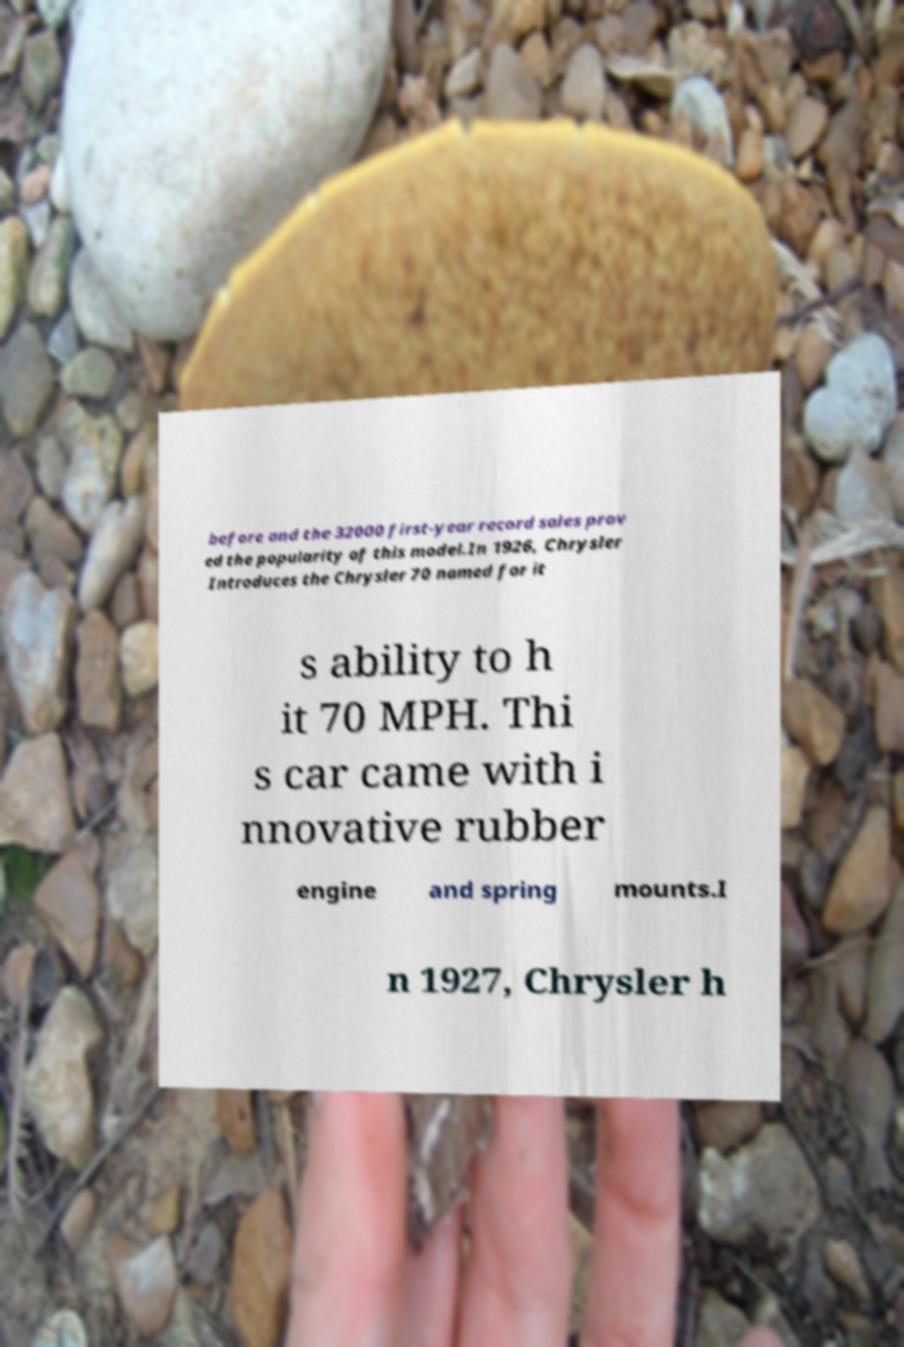There's text embedded in this image that I need extracted. Can you transcribe it verbatim? before and the 32000 first-year record sales prov ed the popularity of this model.In 1926, Chrysler Introduces the Chrysler 70 named for it s ability to h it 70 MPH. Thi s car came with i nnovative rubber engine and spring mounts.I n 1927, Chrysler h 